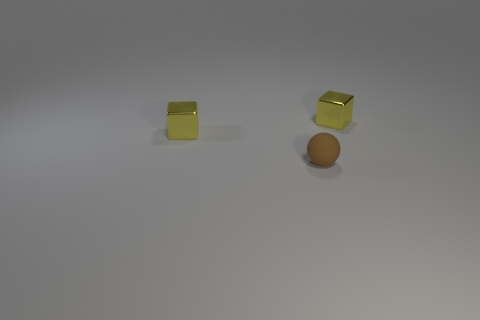There is a small brown thing; how many tiny spheres are behind it? There are no tiny spheres located behind the small brown object in the image. 